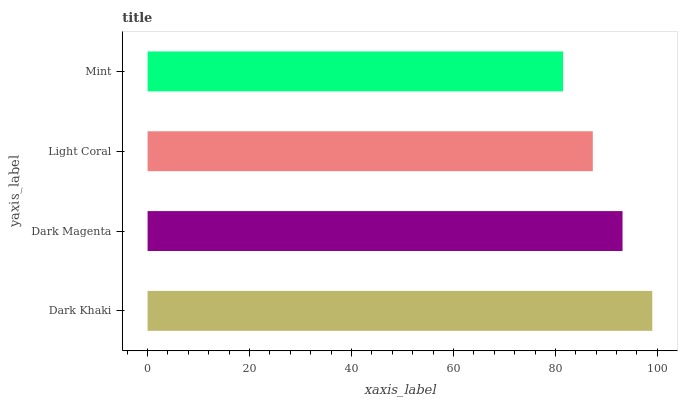Is Mint the minimum?
Answer yes or no. Yes. Is Dark Khaki the maximum?
Answer yes or no. Yes. Is Dark Magenta the minimum?
Answer yes or no. No. Is Dark Magenta the maximum?
Answer yes or no. No. Is Dark Khaki greater than Dark Magenta?
Answer yes or no. Yes. Is Dark Magenta less than Dark Khaki?
Answer yes or no. Yes. Is Dark Magenta greater than Dark Khaki?
Answer yes or no. No. Is Dark Khaki less than Dark Magenta?
Answer yes or no. No. Is Dark Magenta the high median?
Answer yes or no. Yes. Is Light Coral the low median?
Answer yes or no. Yes. Is Light Coral the high median?
Answer yes or no. No. Is Dark Khaki the low median?
Answer yes or no. No. 